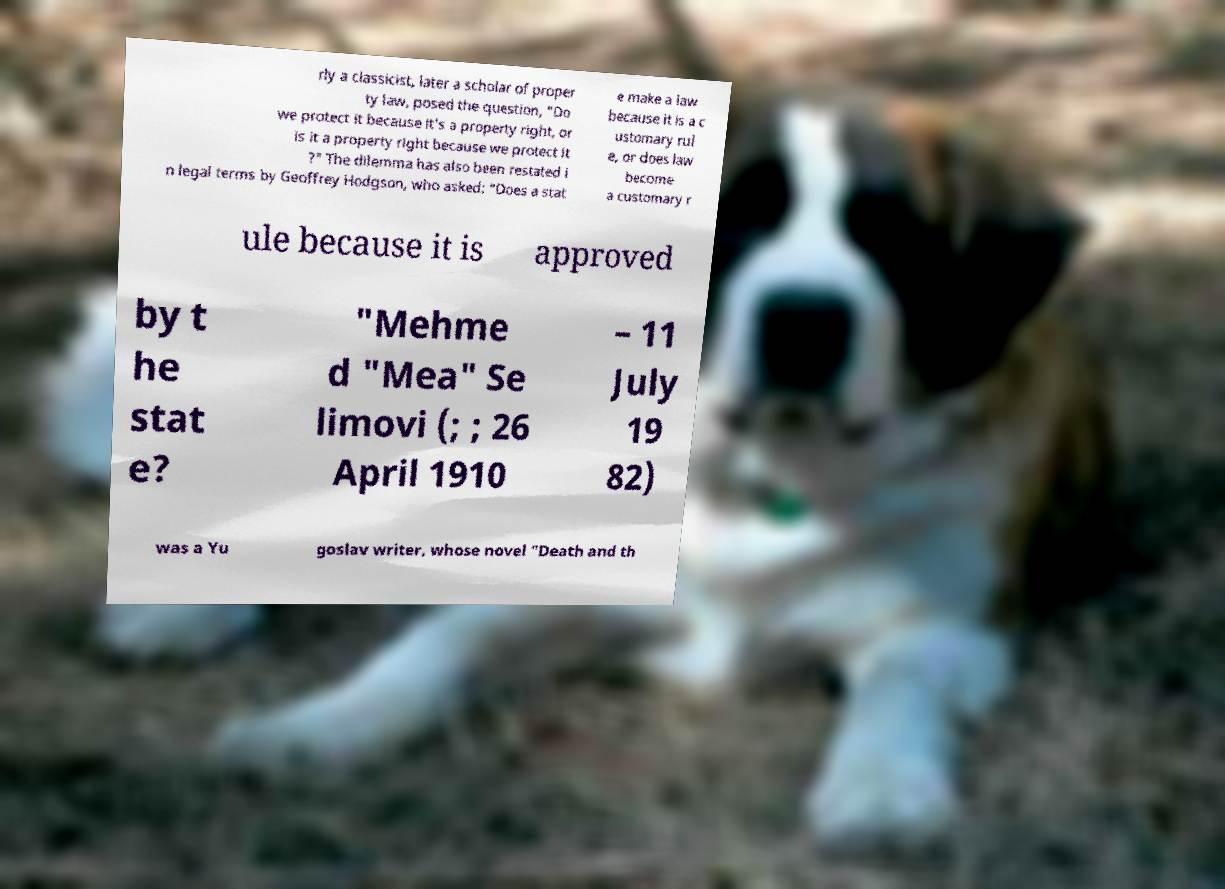Please read and relay the text visible in this image. What does it say? rly a classicist, later a scholar of proper ty law, posed the question, "Do we protect it because it's a property right, or is it a property right because we protect it ?" The dilemma has also been restated i n legal terms by Geoffrey Hodgson, who asked: "Does a stat e make a law because it is a c ustomary rul e, or does law become a customary r ule because it is approved by t he stat e? "Mehme d "Mea" Se limovi (; ; 26 April 1910 – 11 July 19 82) was a Yu goslav writer, whose novel "Death and th 